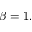Convert formula to latex. <formula><loc_0><loc_0><loc_500><loc_500>\beta = 1 .</formula> 